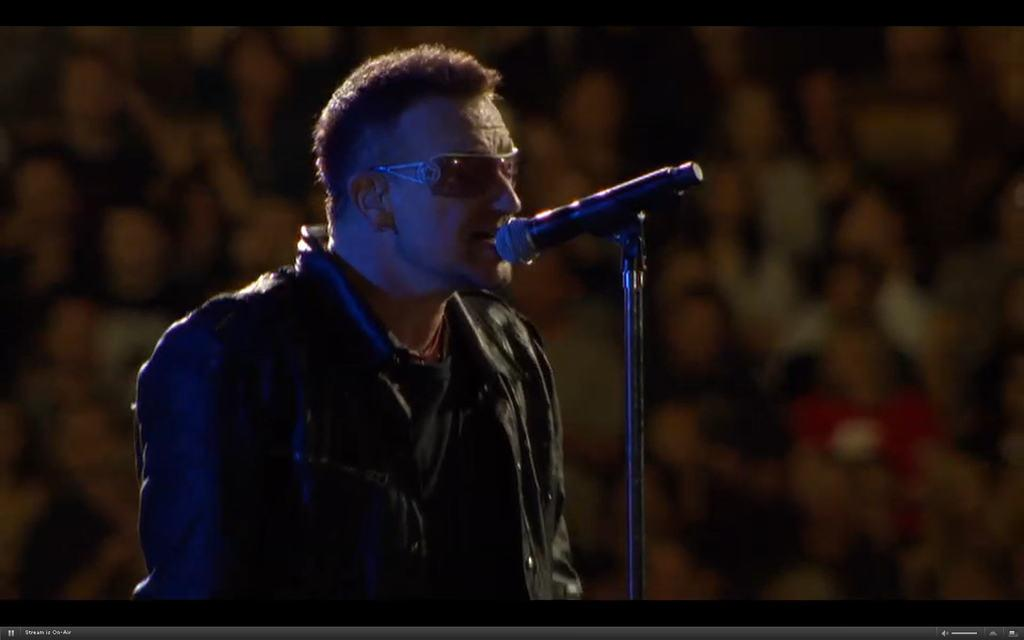What is the main subject of the image? There is a person in the image. What is the person holding in the image? The person is holding a microphone (mike) in the image. Can you describe the person's appearance in the image? The person is wearing black-colored spectacles in the image. What type of pump can be seen in the image? There is no pump present in the image. What stage of development is the person in the image at? The image does not provide any information about the person's development stage. 